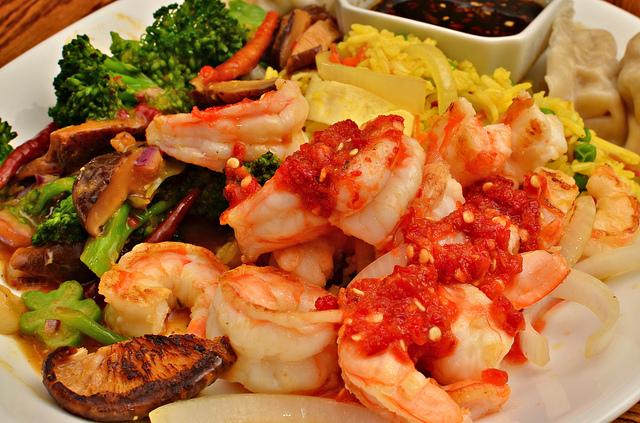What green vegetable is shown?
Write a very short answer. Broccoli. What type of seafood is situated on the plate?
Concise answer only. Shrimp. Is there shrimp on the plate?
Write a very short answer. Yes. What color is the plate?
Quick response, please. White. 